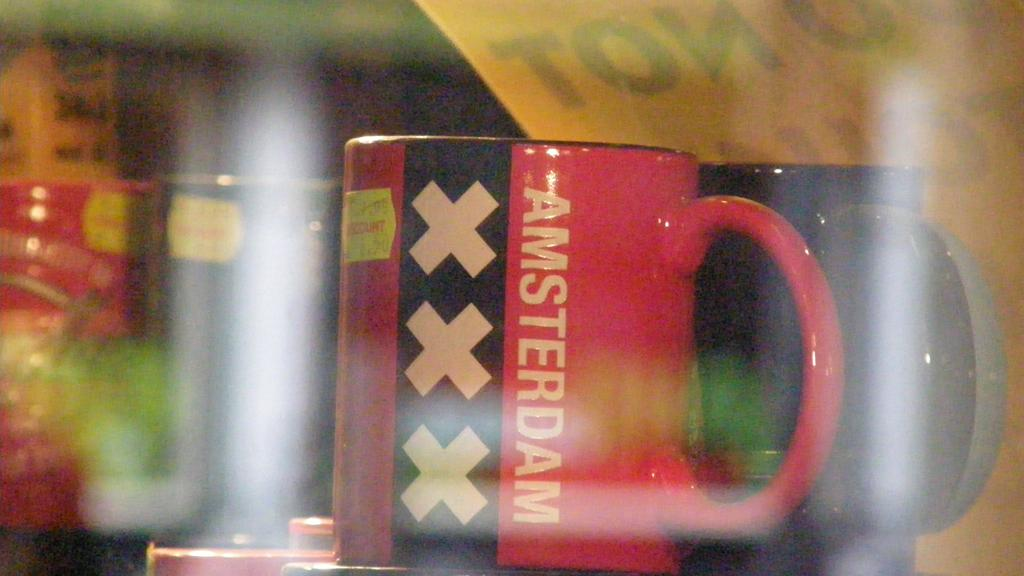<image>
Render a clear and concise summary of the photo. A red and black coffee mug that says Amsterdam on the side. 